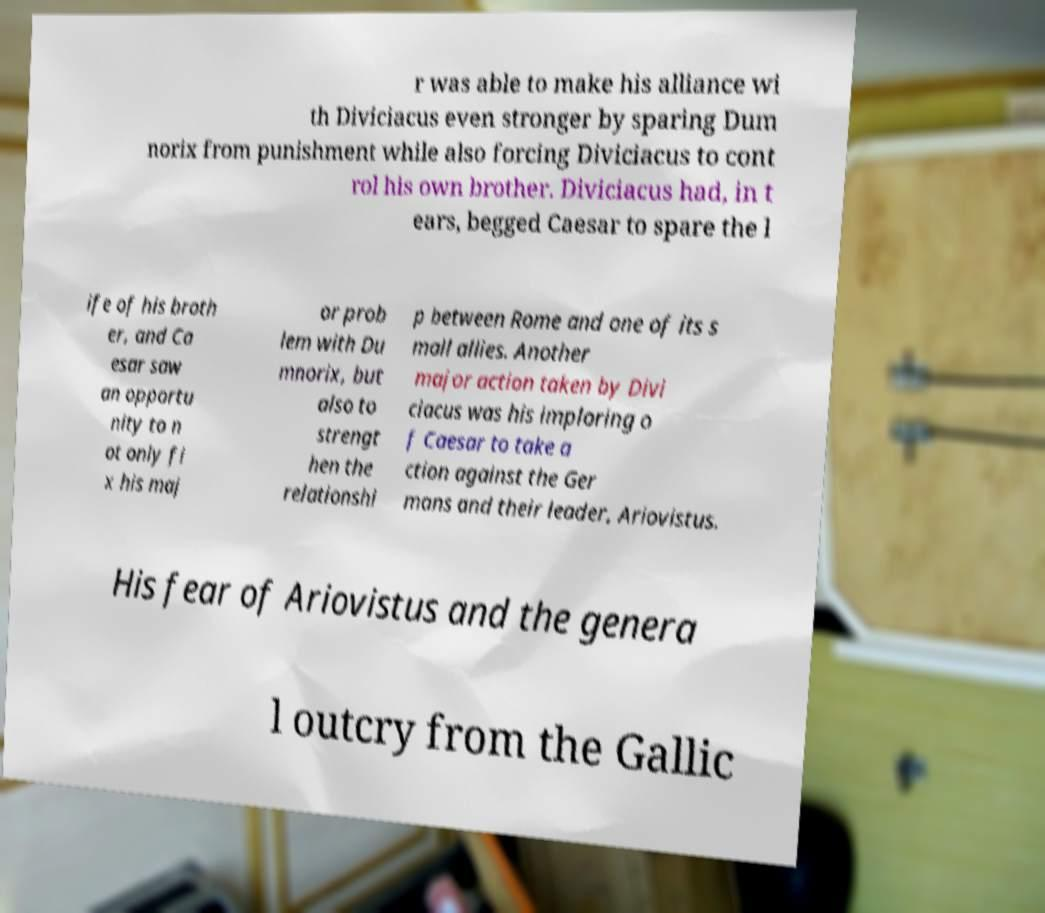For documentation purposes, I need the text within this image transcribed. Could you provide that? r was able to make his alliance wi th Diviciacus even stronger by sparing Dum norix from punishment while also forcing Diviciacus to cont rol his own brother. Diviciacus had, in t ears, begged Caesar to spare the l ife of his broth er, and Ca esar saw an opportu nity to n ot only fi x his maj or prob lem with Du mnorix, but also to strengt hen the relationshi p between Rome and one of its s mall allies. Another major action taken by Divi ciacus was his imploring o f Caesar to take a ction against the Ger mans and their leader, Ariovistus. His fear of Ariovistus and the genera l outcry from the Gallic 